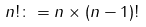<formula> <loc_0><loc_0><loc_500><loc_500>n ! \colon = n \times ( n - 1 ) !</formula> 